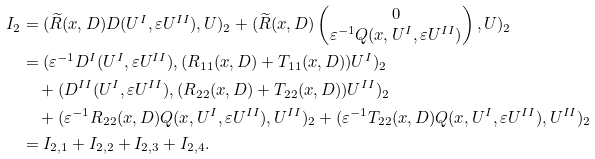Convert formula to latex. <formula><loc_0><loc_0><loc_500><loc_500>I _ { 2 } & = ( \widetilde { R } ( x , D ) D ( U ^ { I } , \varepsilon U ^ { I I } ) , U ) _ { 2 } + ( \widetilde { R } ( x , D ) \begin{pmatrix} 0 \\ \varepsilon ^ { - 1 } Q ( x , U ^ { I } , \varepsilon U ^ { I I } ) \end{pmatrix} , U ) _ { 2 } \\ & = ( \varepsilon ^ { - 1 } D ^ { I } ( U ^ { I } , \varepsilon U ^ { I I } ) , ( R _ { 1 1 } ( x , D ) + T _ { 1 1 } ( x , D ) ) U ^ { I } ) _ { 2 } \\ & \quad + ( D ^ { I I } ( U ^ { I } , \varepsilon U ^ { I I } ) , ( R _ { 2 2 } ( x , D ) + T _ { 2 2 } ( x , D ) ) U ^ { I I } ) _ { 2 } \\ & \quad + ( \varepsilon ^ { - 1 } R _ { 2 2 } ( x , D ) Q ( x , U ^ { I } , \varepsilon U ^ { I I } ) , U ^ { I I } ) _ { 2 } + ( \varepsilon ^ { - 1 } T _ { 2 2 } ( x , D ) Q ( x , U ^ { I } , \varepsilon U ^ { I I } ) , U ^ { I I } ) _ { 2 } \\ & = I _ { 2 , 1 } + I _ { 2 , 2 } + I _ { 2 , 3 } + I _ { 2 , 4 } .</formula> 